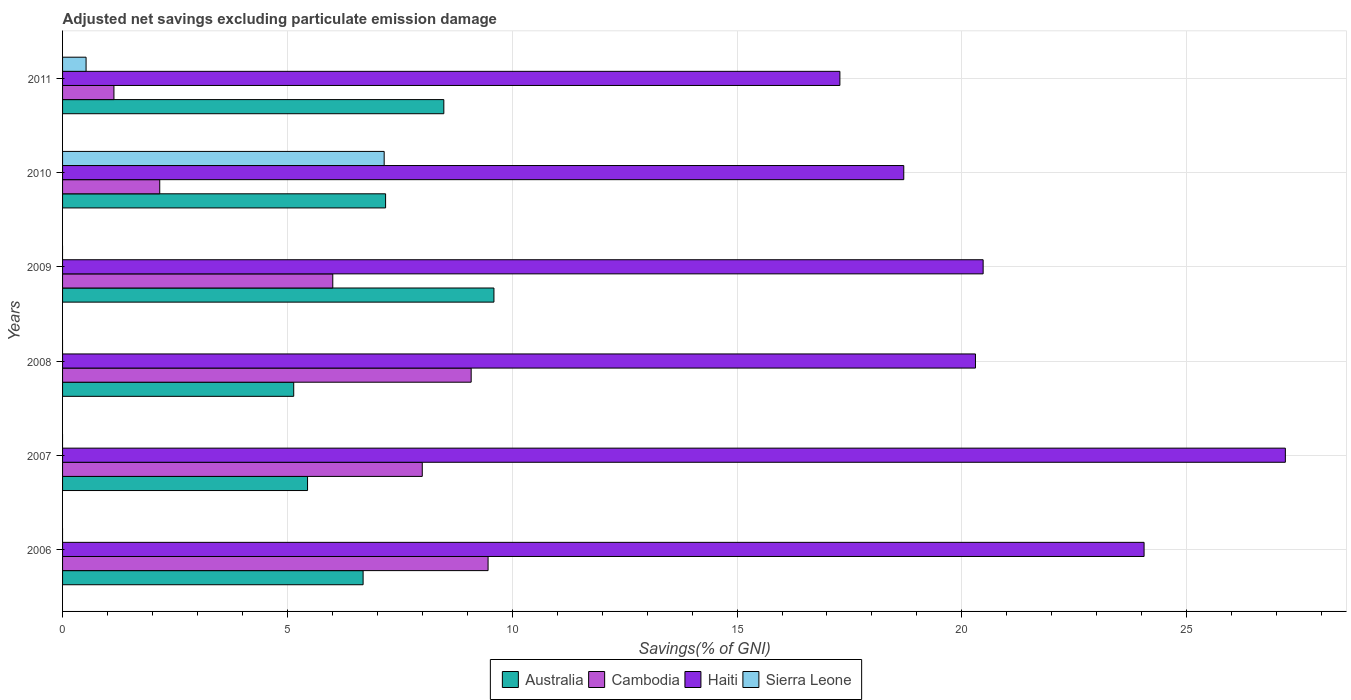How many different coloured bars are there?
Your answer should be very brief. 4. Are the number of bars per tick equal to the number of legend labels?
Offer a very short reply. No. How many bars are there on the 6th tick from the top?
Offer a terse response. 3. How many bars are there on the 4th tick from the bottom?
Provide a succinct answer. 3. In how many cases, is the number of bars for a given year not equal to the number of legend labels?
Your answer should be very brief. 4. What is the adjusted net savings in Australia in 2011?
Give a very brief answer. 8.48. Across all years, what is the maximum adjusted net savings in Australia?
Your answer should be compact. 9.59. Across all years, what is the minimum adjusted net savings in Haiti?
Give a very brief answer. 17.29. What is the total adjusted net savings in Australia in the graph?
Offer a very short reply. 42.53. What is the difference between the adjusted net savings in Haiti in 2008 and that in 2009?
Offer a terse response. -0.17. What is the difference between the adjusted net savings in Sierra Leone in 2009 and the adjusted net savings in Australia in 2011?
Make the answer very short. -8.48. What is the average adjusted net savings in Haiti per year?
Ensure brevity in your answer.  21.34. In the year 2006, what is the difference between the adjusted net savings in Cambodia and adjusted net savings in Australia?
Ensure brevity in your answer.  2.78. In how many years, is the adjusted net savings in Sierra Leone greater than 4 %?
Provide a short and direct response. 1. What is the ratio of the adjusted net savings in Australia in 2008 to that in 2009?
Your answer should be compact. 0.54. Is the difference between the adjusted net savings in Cambodia in 2008 and 2010 greater than the difference between the adjusted net savings in Australia in 2008 and 2010?
Ensure brevity in your answer.  Yes. What is the difference between the highest and the second highest adjusted net savings in Haiti?
Your answer should be compact. 3.14. What is the difference between the highest and the lowest adjusted net savings in Cambodia?
Make the answer very short. 8.32. In how many years, is the adjusted net savings in Haiti greater than the average adjusted net savings in Haiti taken over all years?
Provide a succinct answer. 2. Is the sum of the adjusted net savings in Haiti in 2006 and 2008 greater than the maximum adjusted net savings in Cambodia across all years?
Provide a succinct answer. Yes. How many bars are there?
Offer a terse response. 20. Are the values on the major ticks of X-axis written in scientific E-notation?
Make the answer very short. No. How are the legend labels stacked?
Provide a short and direct response. Horizontal. What is the title of the graph?
Give a very brief answer. Adjusted net savings excluding particulate emission damage. What is the label or title of the X-axis?
Provide a short and direct response. Savings(% of GNI). What is the Savings(% of GNI) in Australia in 2006?
Keep it short and to the point. 6.68. What is the Savings(% of GNI) in Cambodia in 2006?
Your answer should be very brief. 9.46. What is the Savings(% of GNI) in Haiti in 2006?
Ensure brevity in your answer.  24.05. What is the Savings(% of GNI) of Sierra Leone in 2006?
Your answer should be compact. 0. What is the Savings(% of GNI) of Australia in 2007?
Your answer should be very brief. 5.45. What is the Savings(% of GNI) in Cambodia in 2007?
Make the answer very short. 8. What is the Savings(% of GNI) in Haiti in 2007?
Provide a short and direct response. 27.19. What is the Savings(% of GNI) of Sierra Leone in 2007?
Your answer should be compact. 0. What is the Savings(% of GNI) in Australia in 2008?
Provide a succinct answer. 5.14. What is the Savings(% of GNI) of Cambodia in 2008?
Your response must be concise. 9.09. What is the Savings(% of GNI) in Haiti in 2008?
Your answer should be compact. 20.3. What is the Savings(% of GNI) in Sierra Leone in 2008?
Make the answer very short. 0. What is the Savings(% of GNI) in Australia in 2009?
Provide a short and direct response. 9.59. What is the Savings(% of GNI) in Cambodia in 2009?
Your response must be concise. 6.01. What is the Savings(% of GNI) in Haiti in 2009?
Offer a terse response. 20.47. What is the Savings(% of GNI) in Australia in 2010?
Give a very brief answer. 7.18. What is the Savings(% of GNI) of Cambodia in 2010?
Ensure brevity in your answer.  2.16. What is the Savings(% of GNI) in Haiti in 2010?
Provide a succinct answer. 18.71. What is the Savings(% of GNI) in Sierra Leone in 2010?
Keep it short and to the point. 7.15. What is the Savings(% of GNI) of Australia in 2011?
Provide a succinct answer. 8.48. What is the Savings(% of GNI) in Cambodia in 2011?
Offer a very short reply. 1.14. What is the Savings(% of GNI) of Haiti in 2011?
Offer a very short reply. 17.29. What is the Savings(% of GNI) of Sierra Leone in 2011?
Keep it short and to the point. 0.52. Across all years, what is the maximum Savings(% of GNI) of Australia?
Your answer should be compact. 9.59. Across all years, what is the maximum Savings(% of GNI) of Cambodia?
Offer a terse response. 9.46. Across all years, what is the maximum Savings(% of GNI) in Haiti?
Your answer should be compact. 27.19. Across all years, what is the maximum Savings(% of GNI) of Sierra Leone?
Your answer should be compact. 7.15. Across all years, what is the minimum Savings(% of GNI) of Australia?
Keep it short and to the point. 5.14. Across all years, what is the minimum Savings(% of GNI) in Cambodia?
Make the answer very short. 1.14. Across all years, what is the minimum Savings(% of GNI) of Haiti?
Provide a short and direct response. 17.29. Across all years, what is the minimum Savings(% of GNI) in Sierra Leone?
Offer a very short reply. 0. What is the total Savings(% of GNI) of Australia in the graph?
Your answer should be very brief. 42.53. What is the total Savings(% of GNI) of Cambodia in the graph?
Make the answer very short. 35.86. What is the total Savings(% of GNI) in Haiti in the graph?
Your answer should be compact. 128.02. What is the total Savings(% of GNI) in Sierra Leone in the graph?
Give a very brief answer. 7.68. What is the difference between the Savings(% of GNI) in Australia in 2006 and that in 2007?
Offer a very short reply. 1.24. What is the difference between the Savings(% of GNI) of Cambodia in 2006 and that in 2007?
Keep it short and to the point. 1.46. What is the difference between the Savings(% of GNI) of Haiti in 2006 and that in 2007?
Offer a very short reply. -3.14. What is the difference between the Savings(% of GNI) in Australia in 2006 and that in 2008?
Give a very brief answer. 1.54. What is the difference between the Savings(% of GNI) of Cambodia in 2006 and that in 2008?
Offer a terse response. 0.38. What is the difference between the Savings(% of GNI) in Haiti in 2006 and that in 2008?
Offer a very short reply. 3.75. What is the difference between the Savings(% of GNI) of Australia in 2006 and that in 2009?
Your response must be concise. -2.91. What is the difference between the Savings(% of GNI) in Cambodia in 2006 and that in 2009?
Provide a short and direct response. 3.45. What is the difference between the Savings(% of GNI) in Haiti in 2006 and that in 2009?
Provide a succinct answer. 3.58. What is the difference between the Savings(% of GNI) in Australia in 2006 and that in 2010?
Make the answer very short. -0.5. What is the difference between the Savings(% of GNI) of Cambodia in 2006 and that in 2010?
Your answer should be compact. 7.3. What is the difference between the Savings(% of GNI) in Haiti in 2006 and that in 2010?
Your response must be concise. 5.34. What is the difference between the Savings(% of GNI) of Australia in 2006 and that in 2011?
Make the answer very short. -1.8. What is the difference between the Savings(% of GNI) of Cambodia in 2006 and that in 2011?
Make the answer very short. 8.32. What is the difference between the Savings(% of GNI) in Haiti in 2006 and that in 2011?
Give a very brief answer. 6.76. What is the difference between the Savings(% of GNI) of Australia in 2007 and that in 2008?
Provide a short and direct response. 0.31. What is the difference between the Savings(% of GNI) in Cambodia in 2007 and that in 2008?
Your answer should be compact. -1.09. What is the difference between the Savings(% of GNI) in Haiti in 2007 and that in 2008?
Give a very brief answer. 6.89. What is the difference between the Savings(% of GNI) of Australia in 2007 and that in 2009?
Offer a very short reply. -4.15. What is the difference between the Savings(% of GNI) in Cambodia in 2007 and that in 2009?
Offer a very short reply. 1.99. What is the difference between the Savings(% of GNI) of Haiti in 2007 and that in 2009?
Your response must be concise. 6.72. What is the difference between the Savings(% of GNI) in Australia in 2007 and that in 2010?
Provide a succinct answer. -1.74. What is the difference between the Savings(% of GNI) of Cambodia in 2007 and that in 2010?
Offer a very short reply. 5.84. What is the difference between the Savings(% of GNI) of Haiti in 2007 and that in 2010?
Provide a short and direct response. 8.49. What is the difference between the Savings(% of GNI) in Australia in 2007 and that in 2011?
Provide a short and direct response. -3.03. What is the difference between the Savings(% of GNI) in Cambodia in 2007 and that in 2011?
Offer a very short reply. 6.86. What is the difference between the Savings(% of GNI) of Haiti in 2007 and that in 2011?
Provide a short and direct response. 9.91. What is the difference between the Savings(% of GNI) of Australia in 2008 and that in 2009?
Your response must be concise. -4.45. What is the difference between the Savings(% of GNI) in Cambodia in 2008 and that in 2009?
Give a very brief answer. 3.08. What is the difference between the Savings(% of GNI) in Haiti in 2008 and that in 2009?
Your response must be concise. -0.17. What is the difference between the Savings(% of GNI) in Australia in 2008 and that in 2010?
Your answer should be very brief. -2.04. What is the difference between the Savings(% of GNI) of Cambodia in 2008 and that in 2010?
Offer a terse response. 6.93. What is the difference between the Savings(% of GNI) in Haiti in 2008 and that in 2010?
Give a very brief answer. 1.59. What is the difference between the Savings(% of GNI) of Australia in 2008 and that in 2011?
Offer a very short reply. -3.34. What is the difference between the Savings(% of GNI) in Cambodia in 2008 and that in 2011?
Offer a terse response. 7.95. What is the difference between the Savings(% of GNI) in Haiti in 2008 and that in 2011?
Your answer should be compact. 3.02. What is the difference between the Savings(% of GNI) of Australia in 2009 and that in 2010?
Provide a succinct answer. 2.41. What is the difference between the Savings(% of GNI) of Cambodia in 2009 and that in 2010?
Offer a terse response. 3.85. What is the difference between the Savings(% of GNI) of Haiti in 2009 and that in 2010?
Provide a short and direct response. 1.77. What is the difference between the Savings(% of GNI) in Australia in 2009 and that in 2011?
Ensure brevity in your answer.  1.11. What is the difference between the Savings(% of GNI) in Cambodia in 2009 and that in 2011?
Provide a succinct answer. 4.87. What is the difference between the Savings(% of GNI) of Haiti in 2009 and that in 2011?
Provide a succinct answer. 3.19. What is the difference between the Savings(% of GNI) in Australia in 2010 and that in 2011?
Your answer should be very brief. -1.3. What is the difference between the Savings(% of GNI) in Cambodia in 2010 and that in 2011?
Your response must be concise. 1.02. What is the difference between the Savings(% of GNI) of Haiti in 2010 and that in 2011?
Provide a succinct answer. 1.42. What is the difference between the Savings(% of GNI) in Sierra Leone in 2010 and that in 2011?
Provide a succinct answer. 6.63. What is the difference between the Savings(% of GNI) of Australia in 2006 and the Savings(% of GNI) of Cambodia in 2007?
Provide a succinct answer. -1.32. What is the difference between the Savings(% of GNI) of Australia in 2006 and the Savings(% of GNI) of Haiti in 2007?
Your answer should be very brief. -20.51. What is the difference between the Savings(% of GNI) in Cambodia in 2006 and the Savings(% of GNI) in Haiti in 2007?
Your answer should be very brief. -17.73. What is the difference between the Savings(% of GNI) in Australia in 2006 and the Savings(% of GNI) in Cambodia in 2008?
Offer a terse response. -2.4. What is the difference between the Savings(% of GNI) of Australia in 2006 and the Savings(% of GNI) of Haiti in 2008?
Give a very brief answer. -13.62. What is the difference between the Savings(% of GNI) in Cambodia in 2006 and the Savings(% of GNI) in Haiti in 2008?
Offer a very short reply. -10.84. What is the difference between the Savings(% of GNI) of Australia in 2006 and the Savings(% of GNI) of Cambodia in 2009?
Offer a very short reply. 0.67. What is the difference between the Savings(% of GNI) in Australia in 2006 and the Savings(% of GNI) in Haiti in 2009?
Keep it short and to the point. -13.79. What is the difference between the Savings(% of GNI) in Cambodia in 2006 and the Savings(% of GNI) in Haiti in 2009?
Offer a terse response. -11.01. What is the difference between the Savings(% of GNI) in Australia in 2006 and the Savings(% of GNI) in Cambodia in 2010?
Ensure brevity in your answer.  4.52. What is the difference between the Savings(% of GNI) of Australia in 2006 and the Savings(% of GNI) of Haiti in 2010?
Make the answer very short. -12.02. What is the difference between the Savings(% of GNI) of Australia in 2006 and the Savings(% of GNI) of Sierra Leone in 2010?
Your response must be concise. -0.47. What is the difference between the Savings(% of GNI) in Cambodia in 2006 and the Savings(% of GNI) in Haiti in 2010?
Offer a terse response. -9.24. What is the difference between the Savings(% of GNI) in Cambodia in 2006 and the Savings(% of GNI) in Sierra Leone in 2010?
Provide a short and direct response. 2.31. What is the difference between the Savings(% of GNI) in Haiti in 2006 and the Savings(% of GNI) in Sierra Leone in 2010?
Make the answer very short. 16.9. What is the difference between the Savings(% of GNI) in Australia in 2006 and the Savings(% of GNI) in Cambodia in 2011?
Your answer should be very brief. 5.54. What is the difference between the Savings(% of GNI) of Australia in 2006 and the Savings(% of GNI) of Haiti in 2011?
Make the answer very short. -10.6. What is the difference between the Savings(% of GNI) in Australia in 2006 and the Savings(% of GNI) in Sierra Leone in 2011?
Provide a short and direct response. 6.16. What is the difference between the Savings(% of GNI) of Cambodia in 2006 and the Savings(% of GNI) of Haiti in 2011?
Your answer should be very brief. -7.82. What is the difference between the Savings(% of GNI) in Cambodia in 2006 and the Savings(% of GNI) in Sierra Leone in 2011?
Your answer should be compact. 8.94. What is the difference between the Savings(% of GNI) in Haiti in 2006 and the Savings(% of GNI) in Sierra Leone in 2011?
Your response must be concise. 23.53. What is the difference between the Savings(% of GNI) of Australia in 2007 and the Savings(% of GNI) of Cambodia in 2008?
Your answer should be compact. -3.64. What is the difference between the Savings(% of GNI) in Australia in 2007 and the Savings(% of GNI) in Haiti in 2008?
Offer a terse response. -14.85. What is the difference between the Savings(% of GNI) of Cambodia in 2007 and the Savings(% of GNI) of Haiti in 2008?
Offer a very short reply. -12.3. What is the difference between the Savings(% of GNI) of Australia in 2007 and the Savings(% of GNI) of Cambodia in 2009?
Ensure brevity in your answer.  -0.56. What is the difference between the Savings(% of GNI) of Australia in 2007 and the Savings(% of GNI) of Haiti in 2009?
Provide a succinct answer. -15.02. What is the difference between the Savings(% of GNI) of Cambodia in 2007 and the Savings(% of GNI) of Haiti in 2009?
Your answer should be very brief. -12.47. What is the difference between the Savings(% of GNI) in Australia in 2007 and the Savings(% of GNI) in Cambodia in 2010?
Give a very brief answer. 3.29. What is the difference between the Savings(% of GNI) in Australia in 2007 and the Savings(% of GNI) in Haiti in 2010?
Give a very brief answer. -13.26. What is the difference between the Savings(% of GNI) in Australia in 2007 and the Savings(% of GNI) in Sierra Leone in 2010?
Provide a succinct answer. -1.7. What is the difference between the Savings(% of GNI) in Cambodia in 2007 and the Savings(% of GNI) in Haiti in 2010?
Your response must be concise. -10.71. What is the difference between the Savings(% of GNI) of Cambodia in 2007 and the Savings(% of GNI) of Sierra Leone in 2010?
Your response must be concise. 0.85. What is the difference between the Savings(% of GNI) in Haiti in 2007 and the Savings(% of GNI) in Sierra Leone in 2010?
Your response must be concise. 20.04. What is the difference between the Savings(% of GNI) of Australia in 2007 and the Savings(% of GNI) of Cambodia in 2011?
Give a very brief answer. 4.31. What is the difference between the Savings(% of GNI) of Australia in 2007 and the Savings(% of GNI) of Haiti in 2011?
Your response must be concise. -11.84. What is the difference between the Savings(% of GNI) in Australia in 2007 and the Savings(% of GNI) in Sierra Leone in 2011?
Make the answer very short. 4.93. What is the difference between the Savings(% of GNI) in Cambodia in 2007 and the Savings(% of GNI) in Haiti in 2011?
Your answer should be compact. -9.29. What is the difference between the Savings(% of GNI) of Cambodia in 2007 and the Savings(% of GNI) of Sierra Leone in 2011?
Ensure brevity in your answer.  7.48. What is the difference between the Savings(% of GNI) in Haiti in 2007 and the Savings(% of GNI) in Sierra Leone in 2011?
Make the answer very short. 26.67. What is the difference between the Savings(% of GNI) in Australia in 2008 and the Savings(% of GNI) in Cambodia in 2009?
Offer a terse response. -0.87. What is the difference between the Savings(% of GNI) in Australia in 2008 and the Savings(% of GNI) in Haiti in 2009?
Your answer should be compact. -15.33. What is the difference between the Savings(% of GNI) in Cambodia in 2008 and the Savings(% of GNI) in Haiti in 2009?
Give a very brief answer. -11.39. What is the difference between the Savings(% of GNI) of Australia in 2008 and the Savings(% of GNI) of Cambodia in 2010?
Your answer should be compact. 2.98. What is the difference between the Savings(% of GNI) of Australia in 2008 and the Savings(% of GNI) of Haiti in 2010?
Offer a very short reply. -13.57. What is the difference between the Savings(% of GNI) in Australia in 2008 and the Savings(% of GNI) in Sierra Leone in 2010?
Ensure brevity in your answer.  -2.01. What is the difference between the Savings(% of GNI) of Cambodia in 2008 and the Savings(% of GNI) of Haiti in 2010?
Offer a very short reply. -9.62. What is the difference between the Savings(% of GNI) of Cambodia in 2008 and the Savings(% of GNI) of Sierra Leone in 2010?
Your answer should be very brief. 1.94. What is the difference between the Savings(% of GNI) in Haiti in 2008 and the Savings(% of GNI) in Sierra Leone in 2010?
Your answer should be compact. 13.15. What is the difference between the Savings(% of GNI) in Australia in 2008 and the Savings(% of GNI) in Cambodia in 2011?
Give a very brief answer. 4. What is the difference between the Savings(% of GNI) in Australia in 2008 and the Savings(% of GNI) in Haiti in 2011?
Your response must be concise. -12.15. What is the difference between the Savings(% of GNI) in Australia in 2008 and the Savings(% of GNI) in Sierra Leone in 2011?
Provide a short and direct response. 4.62. What is the difference between the Savings(% of GNI) in Cambodia in 2008 and the Savings(% of GNI) in Haiti in 2011?
Give a very brief answer. -8.2. What is the difference between the Savings(% of GNI) in Cambodia in 2008 and the Savings(% of GNI) in Sierra Leone in 2011?
Your answer should be compact. 8.56. What is the difference between the Savings(% of GNI) in Haiti in 2008 and the Savings(% of GNI) in Sierra Leone in 2011?
Your answer should be compact. 19.78. What is the difference between the Savings(% of GNI) of Australia in 2009 and the Savings(% of GNI) of Cambodia in 2010?
Provide a short and direct response. 7.43. What is the difference between the Savings(% of GNI) of Australia in 2009 and the Savings(% of GNI) of Haiti in 2010?
Offer a very short reply. -9.11. What is the difference between the Savings(% of GNI) in Australia in 2009 and the Savings(% of GNI) in Sierra Leone in 2010?
Give a very brief answer. 2.44. What is the difference between the Savings(% of GNI) in Cambodia in 2009 and the Savings(% of GNI) in Haiti in 2010?
Your answer should be compact. -12.7. What is the difference between the Savings(% of GNI) in Cambodia in 2009 and the Savings(% of GNI) in Sierra Leone in 2010?
Your answer should be very brief. -1.14. What is the difference between the Savings(% of GNI) of Haiti in 2009 and the Savings(% of GNI) of Sierra Leone in 2010?
Your answer should be very brief. 13.32. What is the difference between the Savings(% of GNI) in Australia in 2009 and the Savings(% of GNI) in Cambodia in 2011?
Offer a terse response. 8.45. What is the difference between the Savings(% of GNI) of Australia in 2009 and the Savings(% of GNI) of Haiti in 2011?
Ensure brevity in your answer.  -7.69. What is the difference between the Savings(% of GNI) in Australia in 2009 and the Savings(% of GNI) in Sierra Leone in 2011?
Your response must be concise. 9.07. What is the difference between the Savings(% of GNI) of Cambodia in 2009 and the Savings(% of GNI) of Haiti in 2011?
Your response must be concise. -11.28. What is the difference between the Savings(% of GNI) in Cambodia in 2009 and the Savings(% of GNI) in Sierra Leone in 2011?
Your answer should be compact. 5.49. What is the difference between the Savings(% of GNI) in Haiti in 2009 and the Savings(% of GNI) in Sierra Leone in 2011?
Offer a very short reply. 19.95. What is the difference between the Savings(% of GNI) of Australia in 2010 and the Savings(% of GNI) of Cambodia in 2011?
Give a very brief answer. 6.04. What is the difference between the Savings(% of GNI) of Australia in 2010 and the Savings(% of GNI) of Haiti in 2011?
Your answer should be compact. -10.1. What is the difference between the Savings(% of GNI) in Australia in 2010 and the Savings(% of GNI) in Sierra Leone in 2011?
Your answer should be very brief. 6.66. What is the difference between the Savings(% of GNI) in Cambodia in 2010 and the Savings(% of GNI) in Haiti in 2011?
Offer a terse response. -15.13. What is the difference between the Savings(% of GNI) of Cambodia in 2010 and the Savings(% of GNI) of Sierra Leone in 2011?
Your answer should be compact. 1.64. What is the difference between the Savings(% of GNI) of Haiti in 2010 and the Savings(% of GNI) of Sierra Leone in 2011?
Ensure brevity in your answer.  18.19. What is the average Savings(% of GNI) of Australia per year?
Make the answer very short. 7.09. What is the average Savings(% of GNI) of Cambodia per year?
Your response must be concise. 5.98. What is the average Savings(% of GNI) of Haiti per year?
Your answer should be very brief. 21.34. What is the average Savings(% of GNI) in Sierra Leone per year?
Ensure brevity in your answer.  1.28. In the year 2006, what is the difference between the Savings(% of GNI) of Australia and Savings(% of GNI) of Cambodia?
Provide a succinct answer. -2.78. In the year 2006, what is the difference between the Savings(% of GNI) of Australia and Savings(% of GNI) of Haiti?
Your response must be concise. -17.37. In the year 2006, what is the difference between the Savings(% of GNI) of Cambodia and Savings(% of GNI) of Haiti?
Give a very brief answer. -14.59. In the year 2007, what is the difference between the Savings(% of GNI) of Australia and Savings(% of GNI) of Cambodia?
Offer a very short reply. -2.55. In the year 2007, what is the difference between the Savings(% of GNI) in Australia and Savings(% of GNI) in Haiti?
Give a very brief answer. -21.75. In the year 2007, what is the difference between the Savings(% of GNI) of Cambodia and Savings(% of GNI) of Haiti?
Your response must be concise. -19.19. In the year 2008, what is the difference between the Savings(% of GNI) in Australia and Savings(% of GNI) in Cambodia?
Your answer should be very brief. -3.95. In the year 2008, what is the difference between the Savings(% of GNI) in Australia and Savings(% of GNI) in Haiti?
Offer a terse response. -15.16. In the year 2008, what is the difference between the Savings(% of GNI) in Cambodia and Savings(% of GNI) in Haiti?
Your answer should be very brief. -11.22. In the year 2009, what is the difference between the Savings(% of GNI) in Australia and Savings(% of GNI) in Cambodia?
Your response must be concise. 3.58. In the year 2009, what is the difference between the Savings(% of GNI) of Australia and Savings(% of GNI) of Haiti?
Keep it short and to the point. -10.88. In the year 2009, what is the difference between the Savings(% of GNI) of Cambodia and Savings(% of GNI) of Haiti?
Your response must be concise. -14.46. In the year 2010, what is the difference between the Savings(% of GNI) of Australia and Savings(% of GNI) of Cambodia?
Keep it short and to the point. 5.02. In the year 2010, what is the difference between the Savings(% of GNI) of Australia and Savings(% of GNI) of Haiti?
Your answer should be compact. -11.52. In the year 2010, what is the difference between the Savings(% of GNI) in Australia and Savings(% of GNI) in Sierra Leone?
Your response must be concise. 0.03. In the year 2010, what is the difference between the Savings(% of GNI) in Cambodia and Savings(% of GNI) in Haiti?
Provide a succinct answer. -16.55. In the year 2010, what is the difference between the Savings(% of GNI) in Cambodia and Savings(% of GNI) in Sierra Leone?
Provide a succinct answer. -4.99. In the year 2010, what is the difference between the Savings(% of GNI) of Haiti and Savings(% of GNI) of Sierra Leone?
Provide a short and direct response. 11.56. In the year 2011, what is the difference between the Savings(% of GNI) of Australia and Savings(% of GNI) of Cambodia?
Make the answer very short. 7.34. In the year 2011, what is the difference between the Savings(% of GNI) of Australia and Savings(% of GNI) of Haiti?
Ensure brevity in your answer.  -8.81. In the year 2011, what is the difference between the Savings(% of GNI) of Australia and Savings(% of GNI) of Sierra Leone?
Give a very brief answer. 7.96. In the year 2011, what is the difference between the Savings(% of GNI) of Cambodia and Savings(% of GNI) of Haiti?
Offer a terse response. -16.15. In the year 2011, what is the difference between the Savings(% of GNI) of Cambodia and Savings(% of GNI) of Sierra Leone?
Your answer should be compact. 0.62. In the year 2011, what is the difference between the Savings(% of GNI) of Haiti and Savings(% of GNI) of Sierra Leone?
Your response must be concise. 16.76. What is the ratio of the Savings(% of GNI) in Australia in 2006 to that in 2007?
Your answer should be compact. 1.23. What is the ratio of the Savings(% of GNI) in Cambodia in 2006 to that in 2007?
Your response must be concise. 1.18. What is the ratio of the Savings(% of GNI) in Haiti in 2006 to that in 2007?
Offer a very short reply. 0.88. What is the ratio of the Savings(% of GNI) in Australia in 2006 to that in 2008?
Give a very brief answer. 1.3. What is the ratio of the Savings(% of GNI) in Cambodia in 2006 to that in 2008?
Your answer should be very brief. 1.04. What is the ratio of the Savings(% of GNI) in Haiti in 2006 to that in 2008?
Your answer should be very brief. 1.18. What is the ratio of the Savings(% of GNI) of Australia in 2006 to that in 2009?
Your answer should be very brief. 0.7. What is the ratio of the Savings(% of GNI) of Cambodia in 2006 to that in 2009?
Keep it short and to the point. 1.57. What is the ratio of the Savings(% of GNI) of Haiti in 2006 to that in 2009?
Your response must be concise. 1.17. What is the ratio of the Savings(% of GNI) in Australia in 2006 to that in 2010?
Your response must be concise. 0.93. What is the ratio of the Savings(% of GNI) in Cambodia in 2006 to that in 2010?
Give a very brief answer. 4.38. What is the ratio of the Savings(% of GNI) in Haiti in 2006 to that in 2010?
Offer a very short reply. 1.29. What is the ratio of the Savings(% of GNI) in Australia in 2006 to that in 2011?
Your answer should be very brief. 0.79. What is the ratio of the Savings(% of GNI) in Cambodia in 2006 to that in 2011?
Provide a short and direct response. 8.28. What is the ratio of the Savings(% of GNI) in Haiti in 2006 to that in 2011?
Your response must be concise. 1.39. What is the ratio of the Savings(% of GNI) of Australia in 2007 to that in 2008?
Provide a short and direct response. 1.06. What is the ratio of the Savings(% of GNI) in Cambodia in 2007 to that in 2008?
Offer a terse response. 0.88. What is the ratio of the Savings(% of GNI) in Haiti in 2007 to that in 2008?
Offer a terse response. 1.34. What is the ratio of the Savings(% of GNI) of Australia in 2007 to that in 2009?
Make the answer very short. 0.57. What is the ratio of the Savings(% of GNI) of Cambodia in 2007 to that in 2009?
Keep it short and to the point. 1.33. What is the ratio of the Savings(% of GNI) in Haiti in 2007 to that in 2009?
Give a very brief answer. 1.33. What is the ratio of the Savings(% of GNI) in Australia in 2007 to that in 2010?
Keep it short and to the point. 0.76. What is the ratio of the Savings(% of GNI) of Cambodia in 2007 to that in 2010?
Provide a short and direct response. 3.7. What is the ratio of the Savings(% of GNI) in Haiti in 2007 to that in 2010?
Your answer should be compact. 1.45. What is the ratio of the Savings(% of GNI) in Australia in 2007 to that in 2011?
Your response must be concise. 0.64. What is the ratio of the Savings(% of GNI) in Cambodia in 2007 to that in 2011?
Provide a succinct answer. 7. What is the ratio of the Savings(% of GNI) of Haiti in 2007 to that in 2011?
Keep it short and to the point. 1.57. What is the ratio of the Savings(% of GNI) in Australia in 2008 to that in 2009?
Offer a very short reply. 0.54. What is the ratio of the Savings(% of GNI) of Cambodia in 2008 to that in 2009?
Your answer should be compact. 1.51. What is the ratio of the Savings(% of GNI) in Australia in 2008 to that in 2010?
Your answer should be compact. 0.72. What is the ratio of the Savings(% of GNI) of Cambodia in 2008 to that in 2010?
Keep it short and to the point. 4.2. What is the ratio of the Savings(% of GNI) in Haiti in 2008 to that in 2010?
Offer a terse response. 1.09. What is the ratio of the Savings(% of GNI) in Australia in 2008 to that in 2011?
Provide a short and direct response. 0.61. What is the ratio of the Savings(% of GNI) of Cambodia in 2008 to that in 2011?
Keep it short and to the point. 7.96. What is the ratio of the Savings(% of GNI) of Haiti in 2008 to that in 2011?
Your response must be concise. 1.17. What is the ratio of the Savings(% of GNI) in Australia in 2009 to that in 2010?
Ensure brevity in your answer.  1.34. What is the ratio of the Savings(% of GNI) in Cambodia in 2009 to that in 2010?
Give a very brief answer. 2.78. What is the ratio of the Savings(% of GNI) in Haiti in 2009 to that in 2010?
Give a very brief answer. 1.09. What is the ratio of the Savings(% of GNI) in Australia in 2009 to that in 2011?
Keep it short and to the point. 1.13. What is the ratio of the Savings(% of GNI) of Cambodia in 2009 to that in 2011?
Make the answer very short. 5.26. What is the ratio of the Savings(% of GNI) in Haiti in 2009 to that in 2011?
Keep it short and to the point. 1.18. What is the ratio of the Savings(% of GNI) of Australia in 2010 to that in 2011?
Your answer should be compact. 0.85. What is the ratio of the Savings(% of GNI) of Cambodia in 2010 to that in 2011?
Offer a terse response. 1.89. What is the ratio of the Savings(% of GNI) in Haiti in 2010 to that in 2011?
Your answer should be compact. 1.08. What is the ratio of the Savings(% of GNI) in Sierra Leone in 2010 to that in 2011?
Your answer should be compact. 13.68. What is the difference between the highest and the second highest Savings(% of GNI) in Australia?
Offer a terse response. 1.11. What is the difference between the highest and the second highest Savings(% of GNI) of Cambodia?
Your answer should be very brief. 0.38. What is the difference between the highest and the second highest Savings(% of GNI) in Haiti?
Offer a terse response. 3.14. What is the difference between the highest and the lowest Savings(% of GNI) in Australia?
Your answer should be compact. 4.45. What is the difference between the highest and the lowest Savings(% of GNI) of Cambodia?
Make the answer very short. 8.32. What is the difference between the highest and the lowest Savings(% of GNI) of Haiti?
Make the answer very short. 9.91. What is the difference between the highest and the lowest Savings(% of GNI) in Sierra Leone?
Offer a very short reply. 7.15. 